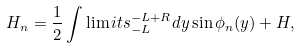Convert formula to latex. <formula><loc_0><loc_0><loc_500><loc_500>H _ { n } = \frac { 1 } { 2 } \int \lim i t s _ { - L } ^ { - L + R } d y \sin \phi _ { n } ( y ) + H ,</formula> 